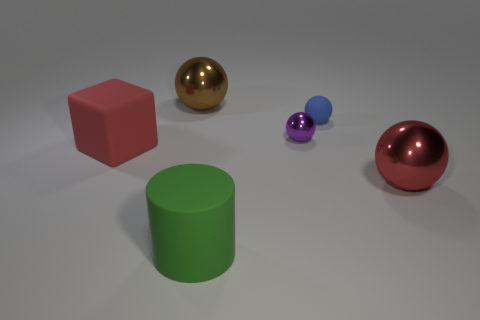Are there any other things that have the same shape as the big red rubber object?
Ensure brevity in your answer.  No. There is a large object that is in front of the large red matte thing and behind the large cylinder; what color is it?
Your answer should be compact. Red. How many blocks are either purple metal objects or large red matte things?
Provide a short and direct response. 1. How many cyan metal objects are the same size as the brown metallic object?
Provide a short and direct response. 0. There is a large red object that is in front of the big red matte thing; what number of green cylinders are left of it?
Provide a short and direct response. 1. There is a thing that is both to the left of the small metallic object and behind the red cube; what is its size?
Your answer should be very brief. Large. Is the number of tiny objects greater than the number of shiny objects?
Offer a terse response. No. Are there any matte spheres of the same color as the tiny metallic sphere?
Your response must be concise. No. Do the metallic ball in front of the red matte block and the large matte cylinder have the same size?
Offer a very short reply. Yes. Is the number of green cylinders less than the number of matte things?
Make the answer very short. Yes. 